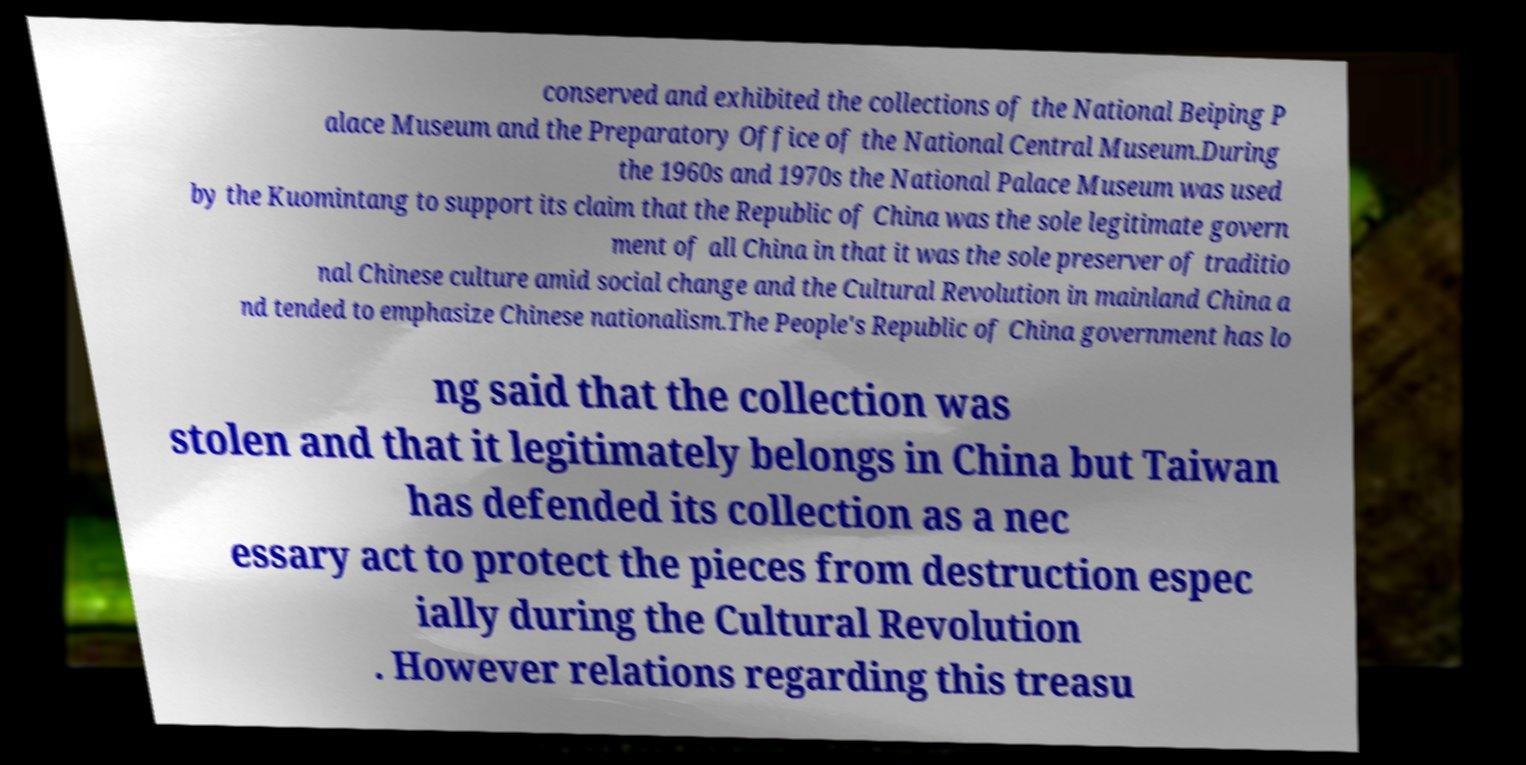There's text embedded in this image that I need extracted. Can you transcribe it verbatim? conserved and exhibited the collections of the National Beiping P alace Museum and the Preparatory Office of the National Central Museum.During the 1960s and 1970s the National Palace Museum was used by the Kuomintang to support its claim that the Republic of China was the sole legitimate govern ment of all China in that it was the sole preserver of traditio nal Chinese culture amid social change and the Cultural Revolution in mainland China a nd tended to emphasize Chinese nationalism.The People's Republic of China government has lo ng said that the collection was stolen and that it legitimately belongs in China but Taiwan has defended its collection as a nec essary act to protect the pieces from destruction espec ially during the Cultural Revolution . However relations regarding this treasu 